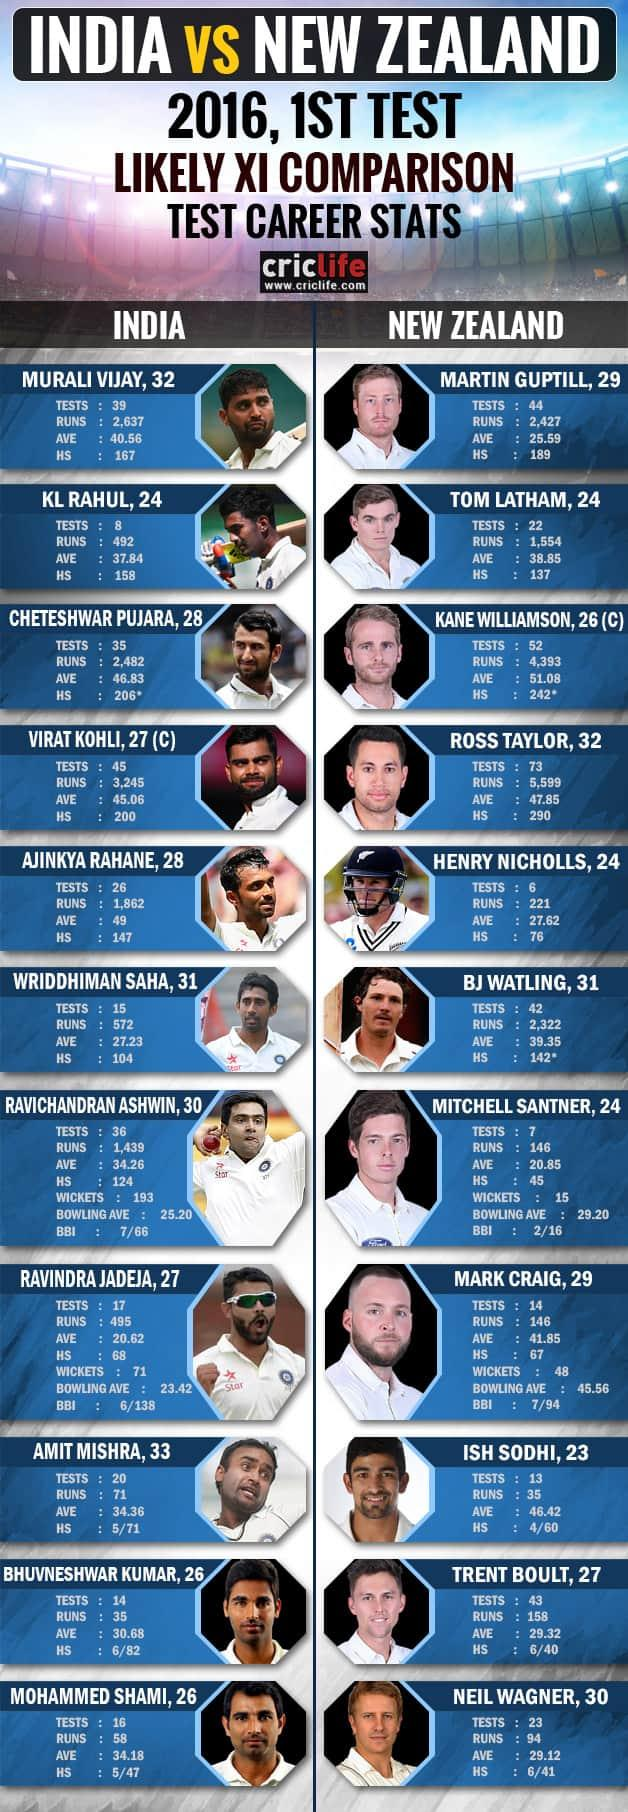List a handful of essential elements in this visual. There are seven players depicted in this infographic with more than 2000 runs. In this infographic, there are three players who have an average of more than 50. The infographic features a number of players, including one who is 28 years old. There are two players in the infographic whose test scores are above 50. There are two players in the infographic who are 30 years old. 